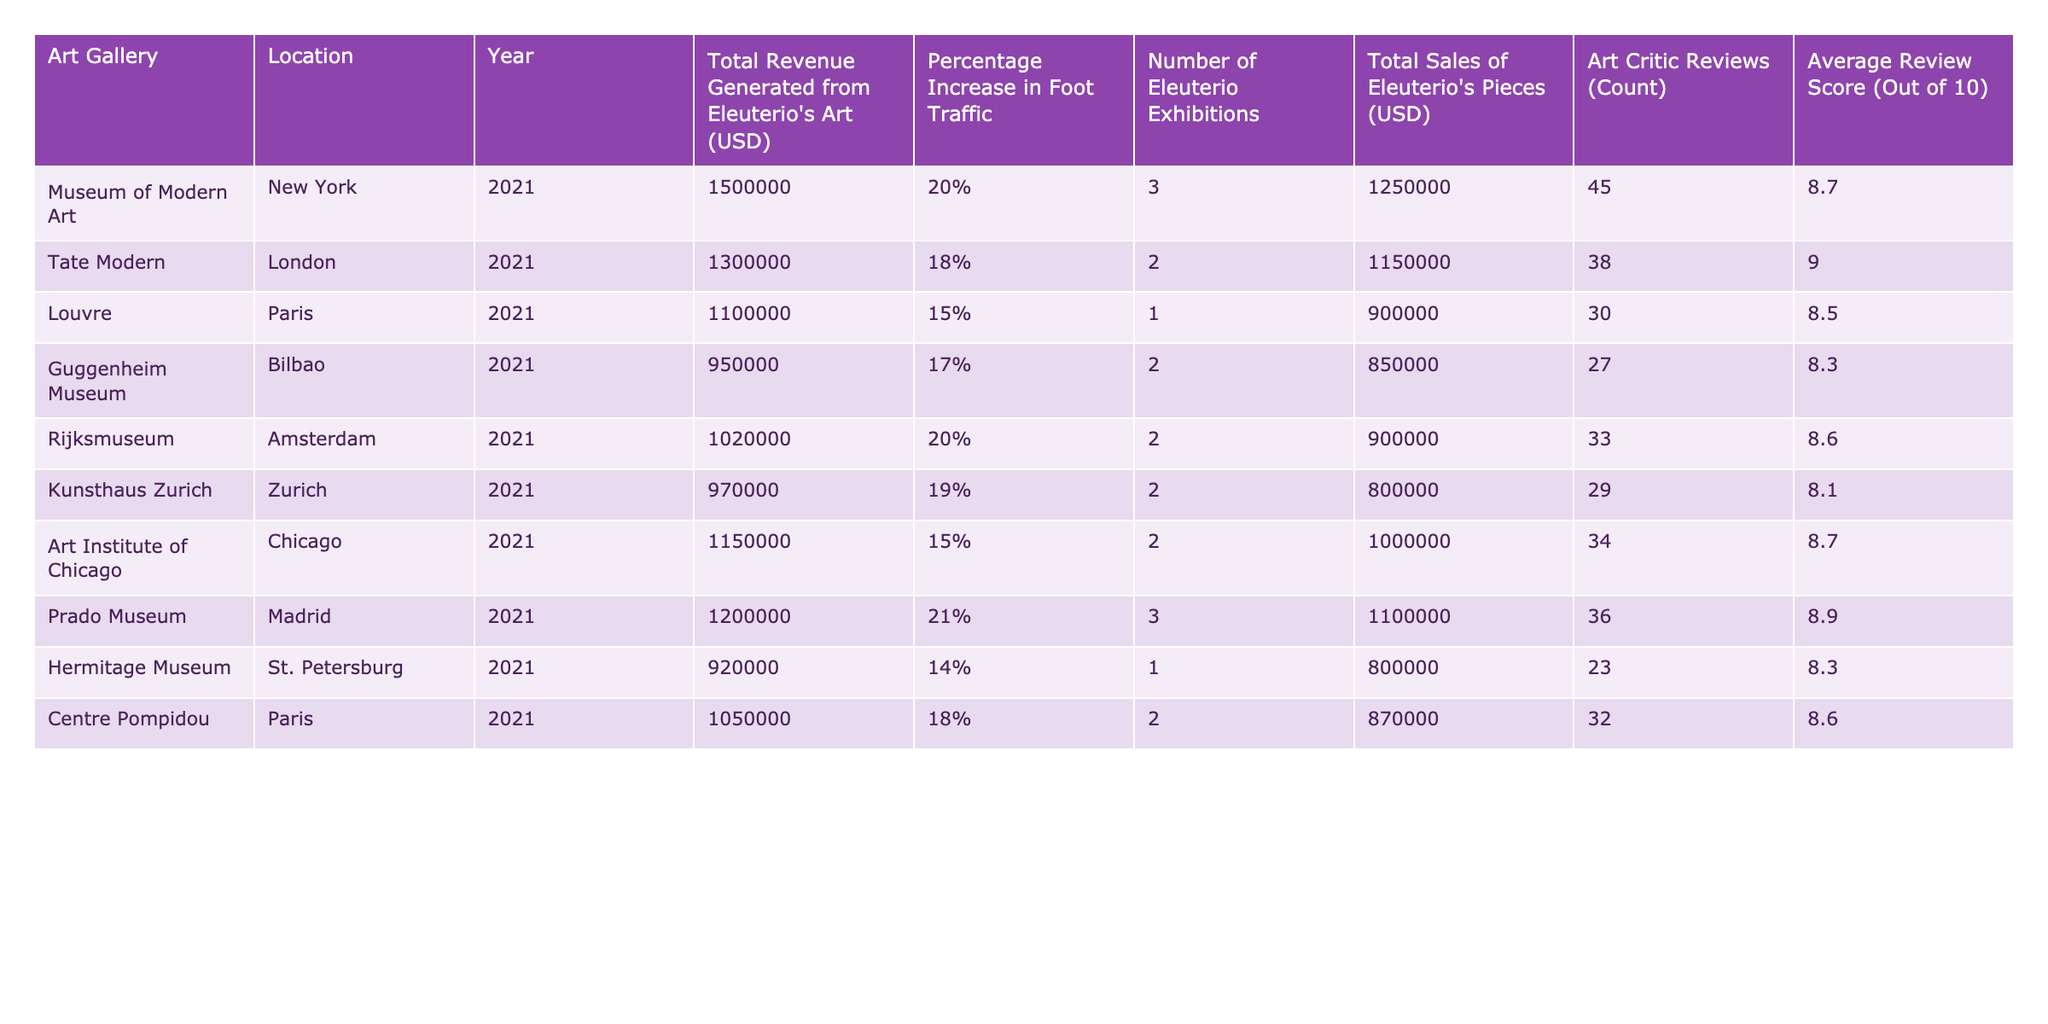What was the total revenue generated from Eleuterio's art at the Museum of Modern Art? The table directly lists the total revenue generated from Eleuterio's art for each gallery. According to the row for the Museum of Modern Art, the value is 1,500,000 USD.
Answer: 1,500,000 USD Which art gallery had the highest average review score? Examining the column for Average Review Score, the highest value is 9.0 associated with the Tate Modern.
Answer: Tate Modern What is the total amount generated from sales of Eleuterio's pieces in all galleries combined? To find the total, sum the Total Sales of Eleuterio's Pieces for each gallery: 1,250,000 + 1,150,000 + 900,000 + 850,000 + 900,000 + 800,000 + 1,000,000 + 1,100,000 + 800,000 + 870,000 = 10,220,000 USD.
Answer: 10,220,000 USD Did the Louvre exhibit more or fewer than two exhibitions of Eleuterio's art? By looking at the Number of Eleuterio Exhibitions for the Louvre, which is 1, it is clear that they exhibited fewer than two exhibitions.
Answer: Fewer What was the percentage increase in foot traffic at the Prado Museum due to Eleuterio’s art? The percentage increase in foot traffic specifically listed for the Prado Museum is 21%, as shown in the relevant row of the table.
Answer: 21% If Eleuterio's exhibitions were increased to 4 at the Rijksmuseum, what would be the new potential total revenue assuming the percentage increase in foot traffic remains the same? With no historical data on the revenue generated from those additional exhibitions, we can project future revenue based on percentage increases if needed. The current Total Revenue is 1,020,000 USD with a foot traffic increase of 20%. Thus, if the revenue increases by 20% with 2 more exhibitions making it 4 total (assuming it would get proportional traffic), the total revenue could be calculated as: 1,020,000 * 1.2 = 1,224,000 USD projected if traffic and prices reflect the increased engagement.
Answer: 1,224,000 USD What is the difference in total sales between the Art Institute of Chicago and the Guggenheim Museum? Calculating the total sales from both galleries: the Art Institute of Chicago (1,000,000 USD) minus the Guggenheim Museum (850,000 USD) gives a difference of 150,000 USD.
Answer: 150,000 USD Does the Hermitage Museum have an average review score above 8.5? Checking the average review score for the Hermitage Museum, which is 8.3, confirms it is below 8.5.
Answer: No What is the average percentage increase in foot traffic across all galleries? To find the average percentage increase, add the foot traffic percentages (20 + 18 + 15 + 17 + 20 + 19 + 15 + 21 + 14 + 18) and then divide by the number of galleries (10). The total is  20 + 18 + 15 + 17 + 20 + 19 + 15 + 21 + 14 + 18 =  195, divided by 10 gives an average of 19.5%.
Answer: 19.5% 